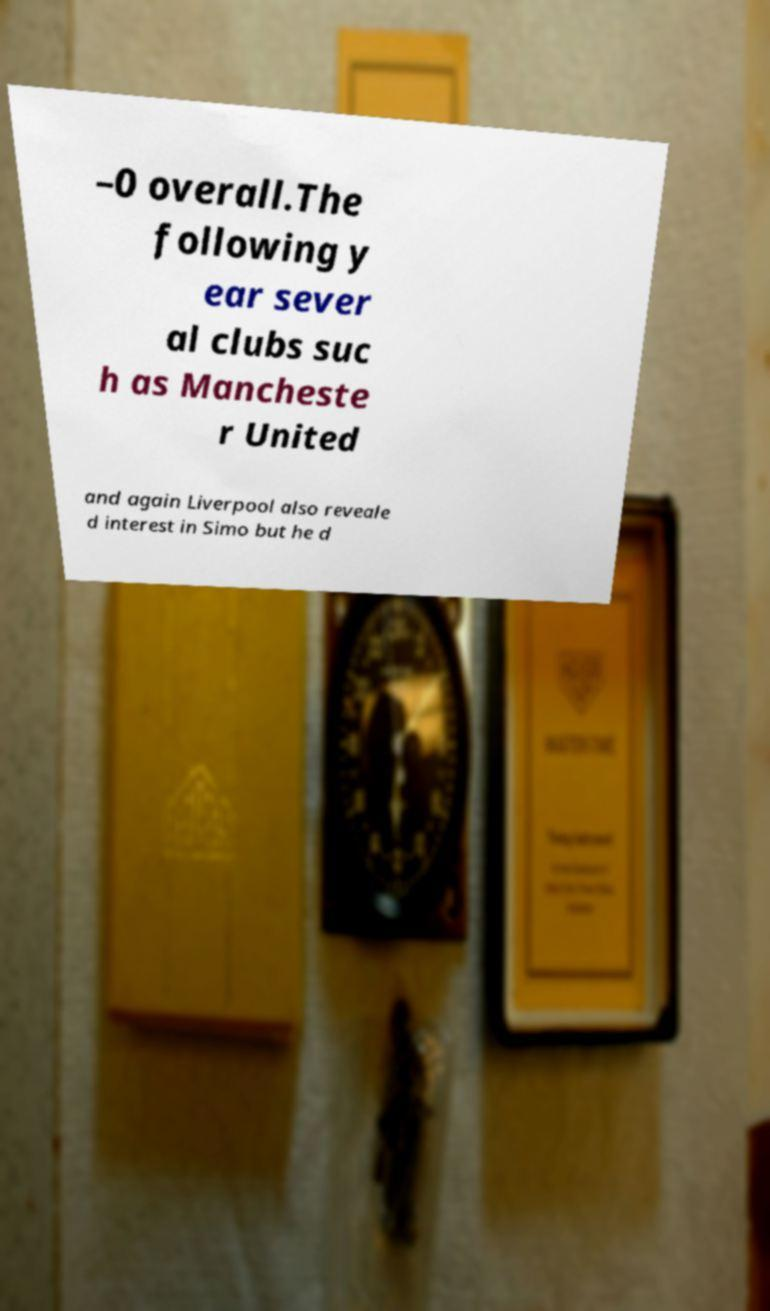For documentation purposes, I need the text within this image transcribed. Could you provide that? –0 overall.The following y ear sever al clubs suc h as Mancheste r United and again Liverpool also reveale d interest in Simo but he d 